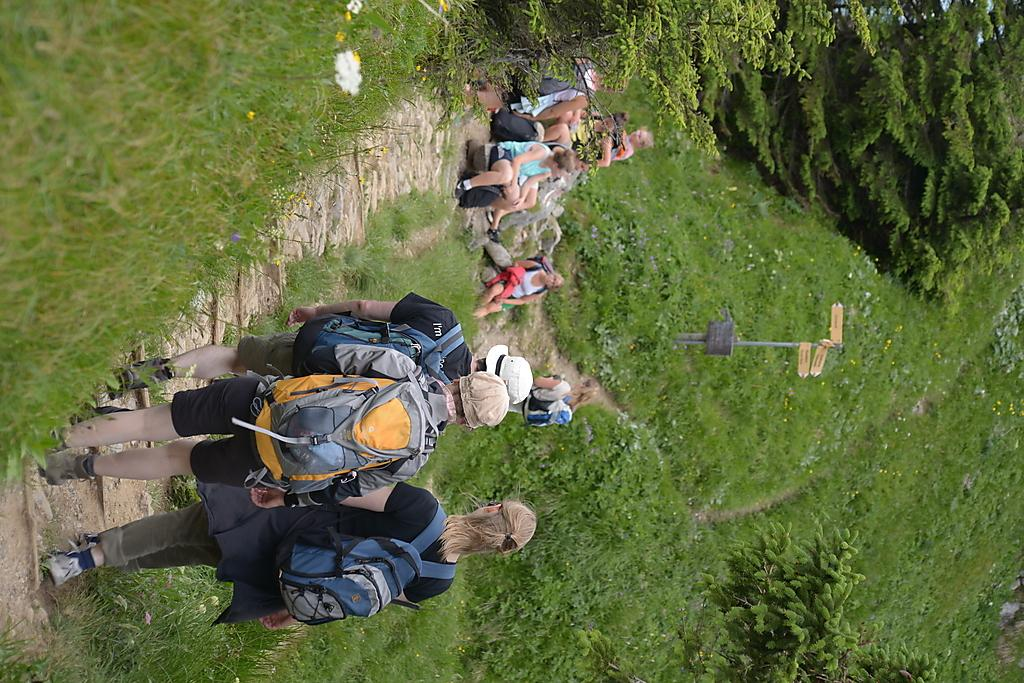What are the people in the image doing? Some people are standing, and some are sitting on the floor in the image. What type of vegetation can be seen in the image? There are trees and plants in the image. What structure is present in the image? There is a pole with boards in the image. What type of advertisement can be seen on the father's shirt in the image? There is no father or advertisement present in the image. What type of tank is visible in the image? There is no tank present in the image. 